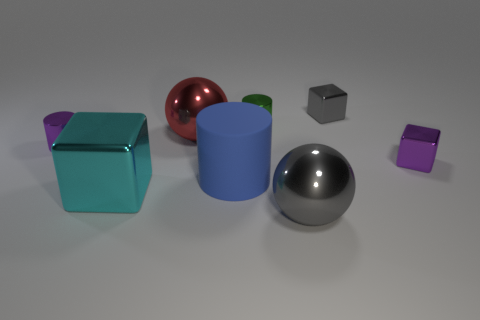There is a gray metal object that is the same size as the blue thing; what is its shape?
Keep it short and to the point. Sphere. How many other blue objects have the same size as the blue rubber thing?
Make the answer very short. 0. What number of things are either small green things or objects that are behind the tiny purple block?
Offer a terse response. 4. Is the size of the block to the left of the large red metallic object the same as the purple object behind the small purple metallic block?
Offer a terse response. No. How many big blue things have the same shape as the tiny gray metal thing?
Provide a short and direct response. 0. What is the shape of the cyan thing that is made of the same material as the green cylinder?
Your response must be concise. Cube. What material is the gray thing that is on the left side of the block that is behind the tiny metallic block in front of the purple metal cylinder?
Provide a short and direct response. Metal. There is a green object; does it have the same size as the purple metal thing behind the purple cube?
Ensure brevity in your answer.  Yes. There is a large blue thing that is the same shape as the green metal object; what is its material?
Make the answer very short. Rubber. What size is the gray metal object that is in front of the tiny purple metal thing to the left of the small metallic block behind the green object?
Provide a succinct answer. Large. 